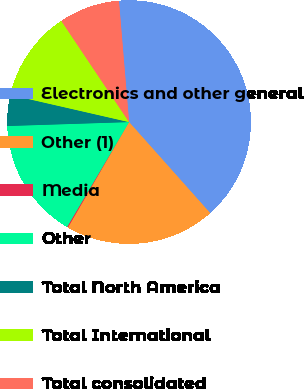<chart> <loc_0><loc_0><loc_500><loc_500><pie_chart><fcel>Electronics and other general<fcel>Other (1)<fcel>Media<fcel>Other<fcel>Total North America<fcel>Total International<fcel>Total consolidated<nl><fcel>39.74%<fcel>19.94%<fcel>0.14%<fcel>15.98%<fcel>4.1%<fcel>12.02%<fcel>8.06%<nl></chart> 